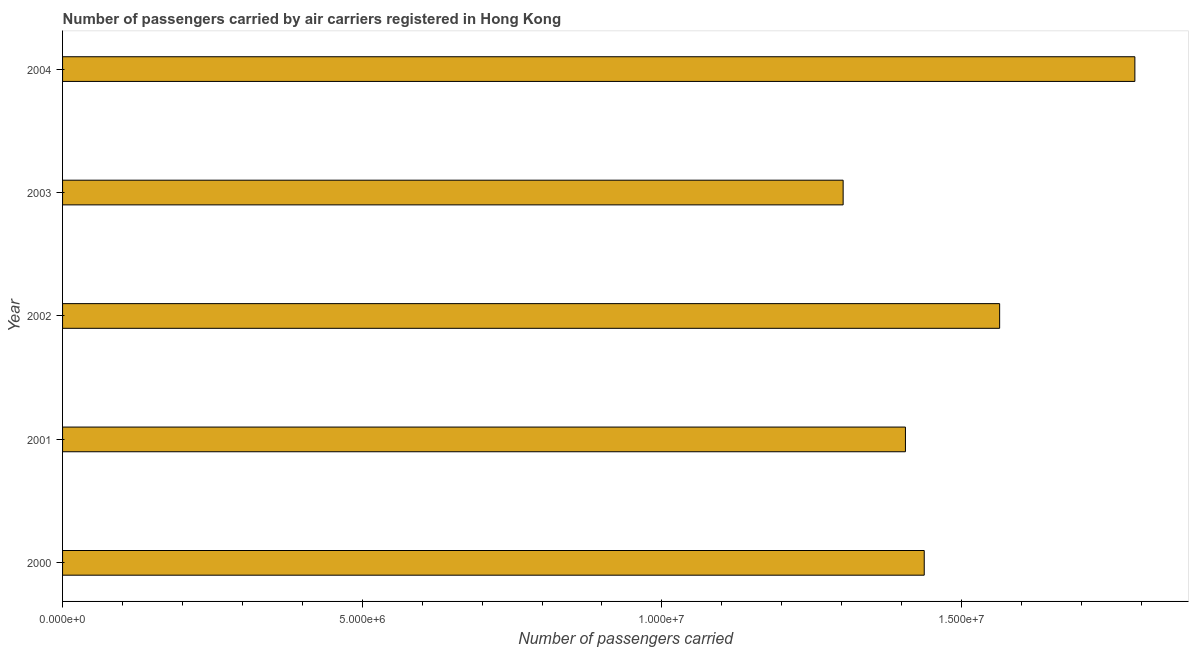Does the graph contain grids?
Offer a terse response. No. What is the title of the graph?
Give a very brief answer. Number of passengers carried by air carriers registered in Hong Kong. What is the label or title of the X-axis?
Your answer should be very brief. Number of passengers carried. What is the number of passengers carried in 2001?
Ensure brevity in your answer.  1.41e+07. Across all years, what is the maximum number of passengers carried?
Make the answer very short. 1.79e+07. Across all years, what is the minimum number of passengers carried?
Make the answer very short. 1.30e+07. In which year was the number of passengers carried maximum?
Give a very brief answer. 2004. What is the sum of the number of passengers carried?
Offer a terse response. 7.50e+07. What is the difference between the number of passengers carried in 2000 and 2004?
Your answer should be very brief. -3.51e+06. What is the average number of passengers carried per year?
Offer a terse response. 1.50e+07. What is the median number of passengers carried?
Your answer should be very brief. 1.44e+07. Is the number of passengers carried in 2002 less than that in 2004?
Provide a succinct answer. Yes. What is the difference between the highest and the second highest number of passengers carried?
Your response must be concise. 2.26e+06. What is the difference between the highest and the lowest number of passengers carried?
Your response must be concise. 4.87e+06. How many years are there in the graph?
Provide a short and direct response. 5. Are the values on the major ticks of X-axis written in scientific E-notation?
Give a very brief answer. Yes. What is the Number of passengers carried of 2000?
Make the answer very short. 1.44e+07. What is the Number of passengers carried of 2001?
Your response must be concise. 1.41e+07. What is the Number of passengers carried of 2002?
Provide a succinct answer. 1.56e+07. What is the Number of passengers carried in 2003?
Keep it short and to the point. 1.30e+07. What is the Number of passengers carried of 2004?
Make the answer very short. 1.79e+07. What is the difference between the Number of passengers carried in 2000 and 2001?
Your answer should be very brief. 3.14e+05. What is the difference between the Number of passengers carried in 2000 and 2002?
Your response must be concise. -1.26e+06. What is the difference between the Number of passengers carried in 2000 and 2003?
Your answer should be compact. 1.35e+06. What is the difference between the Number of passengers carried in 2000 and 2004?
Ensure brevity in your answer.  -3.51e+06. What is the difference between the Number of passengers carried in 2001 and 2002?
Give a very brief answer. -1.57e+06. What is the difference between the Number of passengers carried in 2001 and 2003?
Your response must be concise. 1.04e+06. What is the difference between the Number of passengers carried in 2001 and 2004?
Provide a succinct answer. -3.83e+06. What is the difference between the Number of passengers carried in 2002 and 2003?
Ensure brevity in your answer.  2.61e+06. What is the difference between the Number of passengers carried in 2002 and 2004?
Provide a succinct answer. -2.26e+06. What is the difference between the Number of passengers carried in 2003 and 2004?
Your response must be concise. -4.87e+06. What is the ratio of the Number of passengers carried in 2000 to that in 2001?
Offer a terse response. 1.02. What is the ratio of the Number of passengers carried in 2000 to that in 2002?
Your answer should be very brief. 0.92. What is the ratio of the Number of passengers carried in 2000 to that in 2003?
Ensure brevity in your answer.  1.1. What is the ratio of the Number of passengers carried in 2000 to that in 2004?
Give a very brief answer. 0.8. What is the ratio of the Number of passengers carried in 2001 to that in 2002?
Give a very brief answer. 0.9. What is the ratio of the Number of passengers carried in 2001 to that in 2003?
Offer a very short reply. 1.08. What is the ratio of the Number of passengers carried in 2001 to that in 2004?
Your answer should be compact. 0.79. What is the ratio of the Number of passengers carried in 2002 to that in 2003?
Give a very brief answer. 1.2. What is the ratio of the Number of passengers carried in 2002 to that in 2004?
Give a very brief answer. 0.87. What is the ratio of the Number of passengers carried in 2003 to that in 2004?
Ensure brevity in your answer.  0.73. 